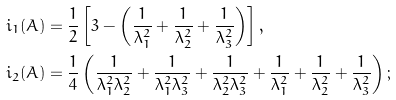<formula> <loc_0><loc_0><loc_500><loc_500>i _ { 1 } ( A ) & = \frac { 1 } { 2 } \left [ 3 - \left ( \frac { 1 } { \lambda _ { 1 } ^ { 2 } } + \frac { 1 } { \lambda _ { 2 } ^ { 2 } } + \frac { 1 } { \lambda _ { 3 } ^ { 2 } } \right ) \right ] , \\ i _ { 2 } ( A ) & = \frac { 1 } { 4 } \left ( \frac { 1 } { \lambda _ { 1 } ^ { 2 } \lambda _ { 2 } ^ { 2 } } + \frac { 1 } { \lambda _ { 1 } ^ { 2 } \lambda _ { 3 } ^ { 2 } } + \frac { 1 } { \lambda _ { 2 } ^ { 2 } \lambda _ { 3 } ^ { 2 } } + \frac { 1 } { \lambda _ { 1 } ^ { 2 } } + \frac { 1 } { \lambda _ { 2 } ^ { 2 } } + \frac { 1 } { \lambda _ { 3 } ^ { 2 } } \right ) ;</formula> 